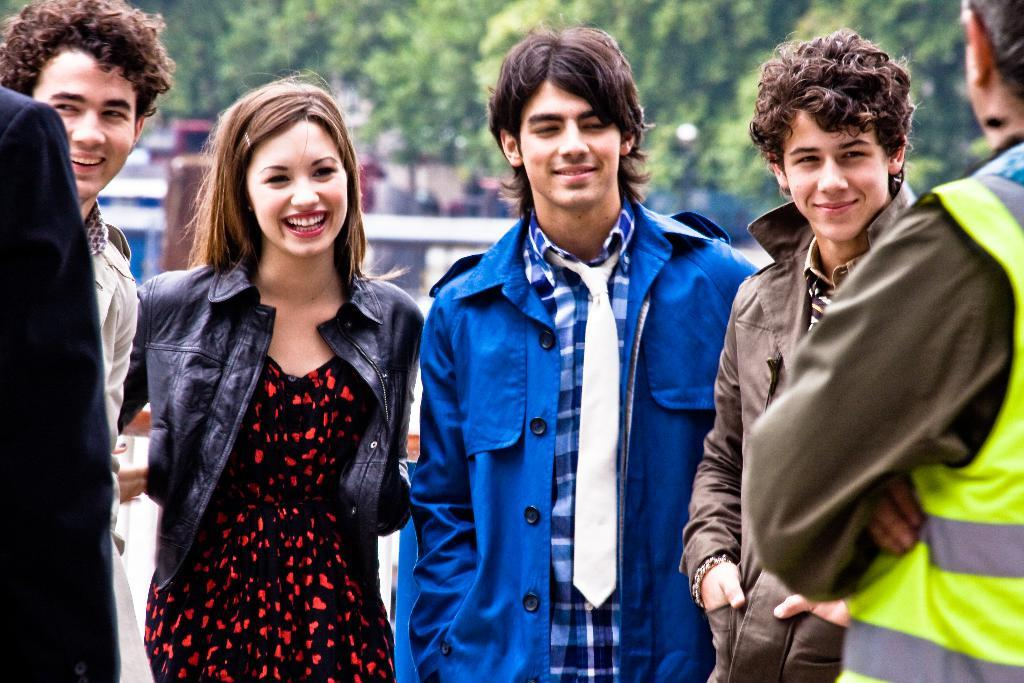What can be seen in the foreground of the image? There are people standing in the front of the image. What is visible in the background of the image? There are buildings and trees in the background of the image. Where is the map located in the image? There is no map present in the image. What type of fire can be seen in the image? There is no fire present in the image. 